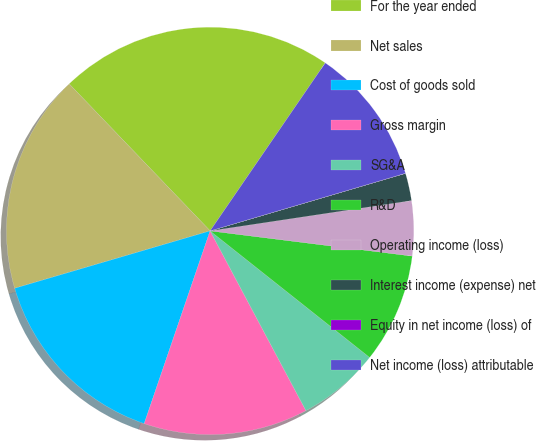Convert chart. <chart><loc_0><loc_0><loc_500><loc_500><pie_chart><fcel>For the year ended<fcel>Net sales<fcel>Cost of goods sold<fcel>Gross margin<fcel>SG&A<fcel>R&D<fcel>Operating income (loss)<fcel>Interest income (expense) net<fcel>Equity in net income (loss) of<fcel>Net income (loss) attributable<nl><fcel>21.73%<fcel>17.38%<fcel>15.21%<fcel>13.04%<fcel>6.53%<fcel>8.7%<fcel>4.35%<fcel>2.18%<fcel>0.01%<fcel>10.87%<nl></chart> 